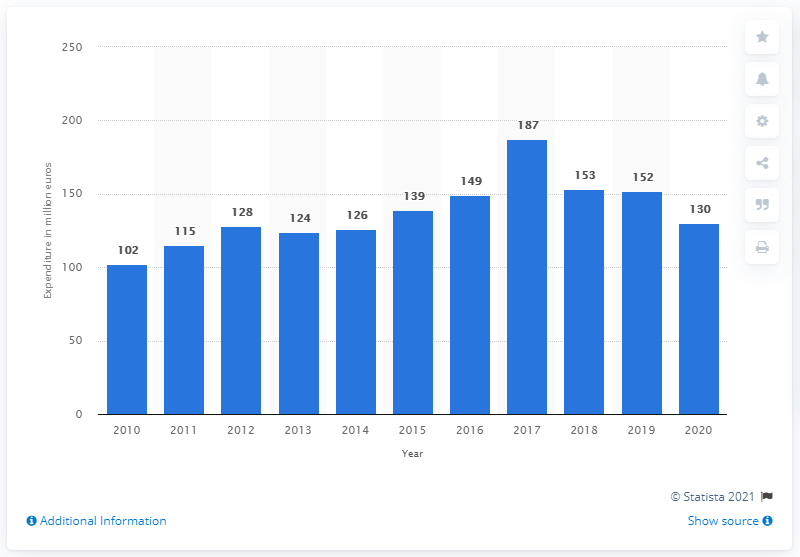Identify some key points in this picture. The adidas Group spent approximately 130 million euros on research and development in 2020. 